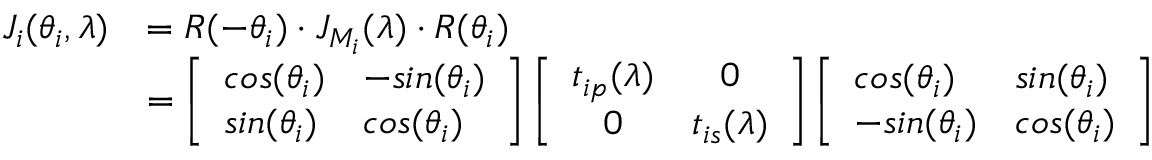<formula> <loc_0><loc_0><loc_500><loc_500>\begin{array} { r l } { J _ { i } ( \theta _ { i } , \lambda ) } & { = R ( - \theta _ { i } ) \cdot J _ { M _ { i } } ( \lambda ) \cdot R ( \theta _ { i } ) } \\ & { = \left [ \begin{array} { l l } { \cos ( \theta _ { i } ) } & { - \sin ( \theta _ { i } ) } \\ { \sin ( \theta _ { i } ) } & { \cos ( \theta _ { i } ) } \end{array} \right ] \left [ \begin{array} { c c } { t _ { i p } ( \lambda ) } & { 0 } \\ { 0 } & { t _ { i s } ( \lambda ) } \end{array} \right ] \left [ \begin{array} { l l } { \cos ( \theta _ { i } ) } & { \sin ( \theta _ { i } ) } \\ { - \sin ( \theta _ { i } ) } & { \cos ( \theta _ { i } ) } \end{array} \right ] } \end{array}</formula> 